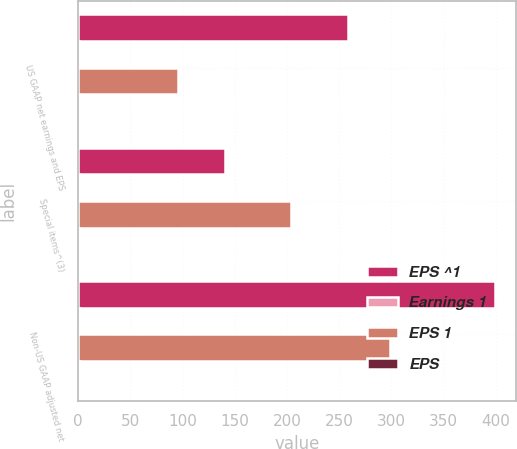Convert chart. <chart><loc_0><loc_0><loc_500><loc_500><stacked_bar_chart><ecel><fcel>US GAAP net earnings and EPS<fcel>Special items^(3)<fcel>Non-US GAAP adjusted net<nl><fcel>EPS ^1<fcel>258.1<fcel>140.8<fcel>398.9<nl><fcel>Earnings 1<fcel>1.2<fcel>0.66<fcel>1.86<nl><fcel>EPS 1<fcel>95.3<fcel>203.8<fcel>299.1<nl><fcel>EPS<fcel>0.44<fcel>0.95<fcel>1.39<nl></chart> 